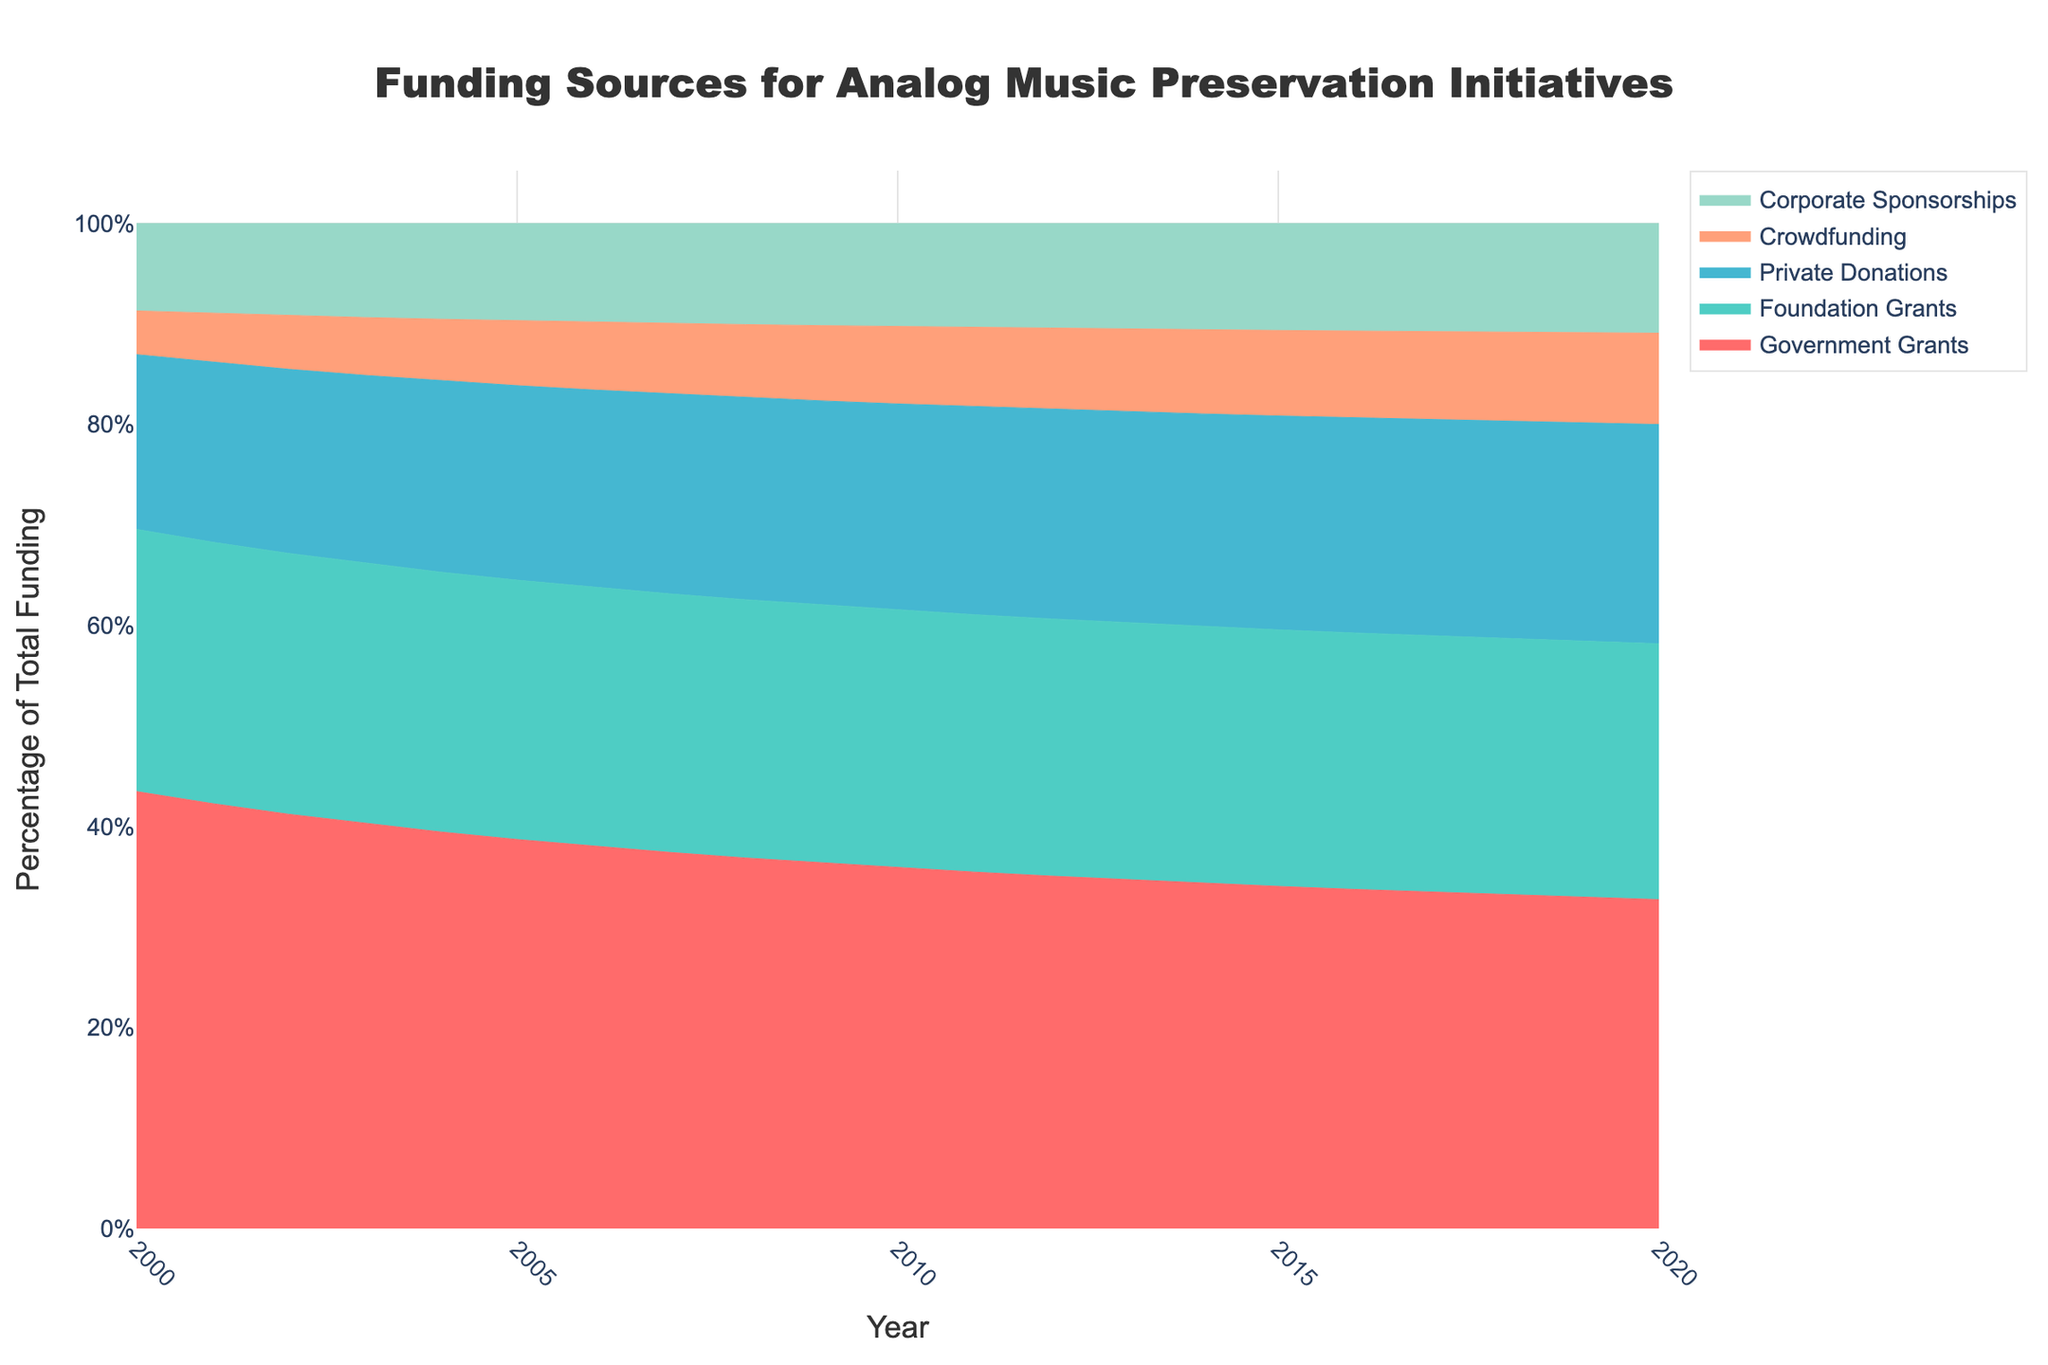what are the main funding sources shown in the chart? By looking at the legend, the chart includes Government Grants, Foundation Grants, Private Donations, Crowdfunding, and Corporate Sponsorships as funding sources.
Answer: Government Grants, Foundation Grants, Private Donations, Crowdfunding, Corporate Sponsorships what is the overall trend for Government Grants? By examining the stacked area for Government Grants over the years, it consistently occupies the largest area and remains relatively stable in percentage.
Answer: Stable which funding source had an increasing trend from 2000 to 2020? By observing the colors representing each funding source, Crowdfunding and Corporate Sponsorships show an increase over time.
Answer: Crowdfunding, Corporate Sponsorships how did the proportion of Private Donations change from 2000 to 2020? Analyzing the height of the Private Donations area, it appears to have increased slightly over time, but less drastically compared to other sources.
Answer: Slight increase which year had the highest total funding? The chart shows funding as 100% of the total each year, so the year is inconsequential for the maximum total funding. All years are equal in total percentage.
Answer: All years equal what was the proportion of Foundation Grants in-year 2005? By looking at the height of the Foundation Grants area in 2005, it appears to be around 28% (since each color and their percentages sum up to 100% annually).
Answer: ~28% compare the proportion of Crowdfunding vs. Corporate Sponsorships in 2010? Crowdfunding appears to occupy a smaller area compared to Corporate Sponsorships for the year 2010.
Answer: Corporate Sponsorships larger how did the proportion of Government Grants change between 2000 and 2020? Government Grants show relatively stable percentages over time with a slight decrease, occupying the largest area consistently but gradually getting smaller.
Answer: Slight decrease what is the smallest funding source in 2000? Crowdfunding appears to be the smallest portion in the year 2000, occupying the least area.
Answer: Crowdfunding which funding source shows the most consistent trend over the 20-year period? Government Grants show the most consistent trend as they maintain a sizeable, mostly stable area over the years.
Answer: Government Grants 